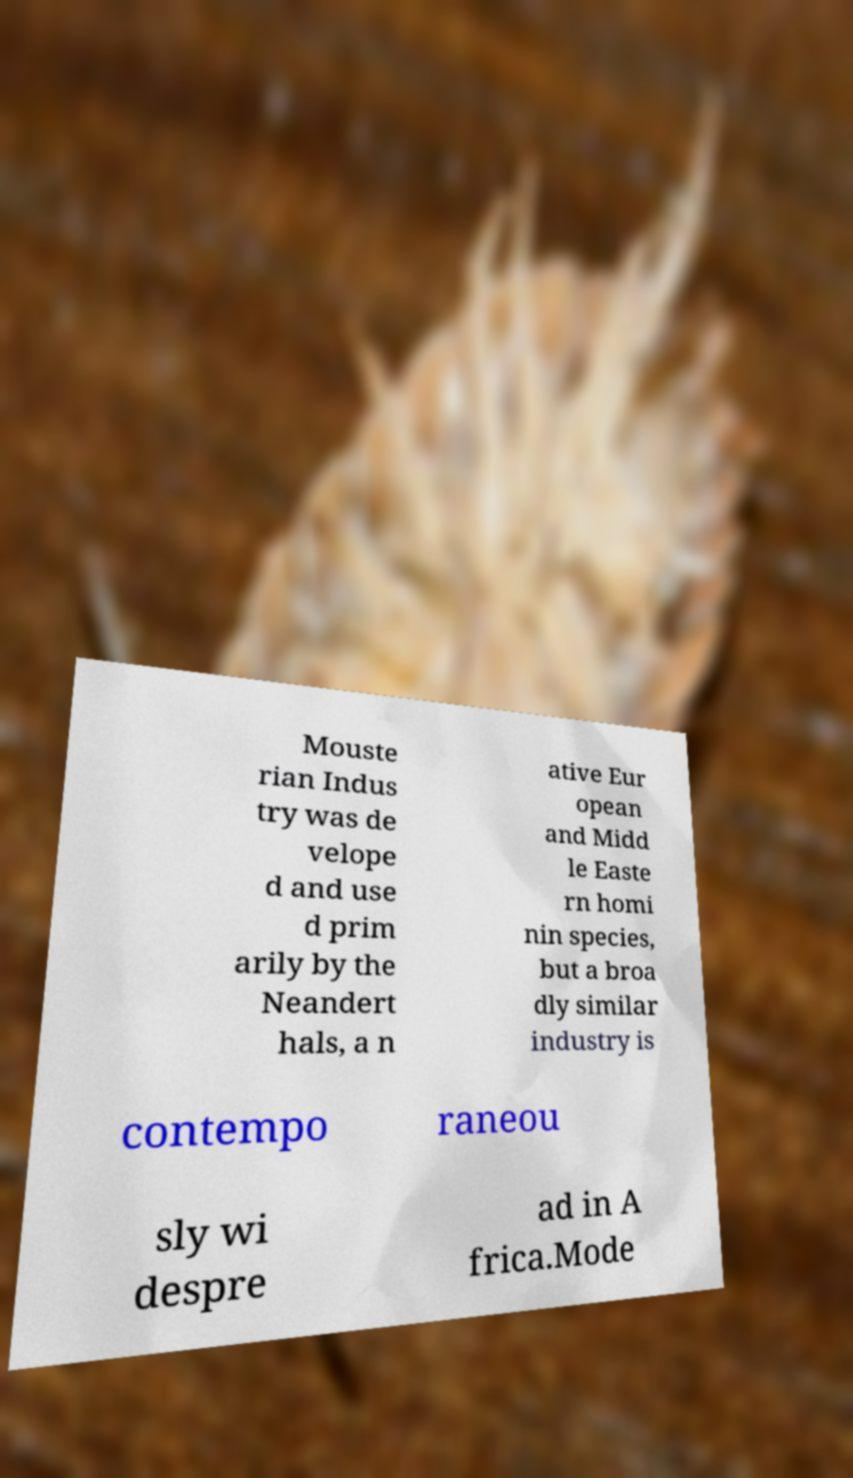Can you accurately transcribe the text from the provided image for me? Mouste rian Indus try was de velope d and use d prim arily by the Neandert hals, a n ative Eur opean and Midd le Easte rn homi nin species, but a broa dly similar industry is contempo raneou sly wi despre ad in A frica.Mode 